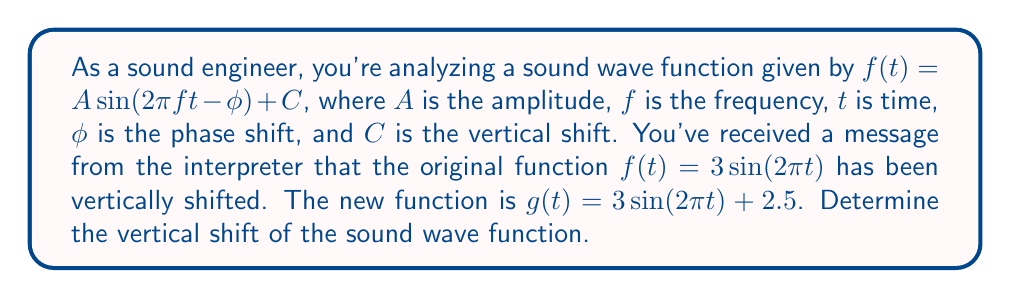Solve this math problem. To determine the vertical shift of a function, we need to compare the original function with the transformed function. Let's analyze this step-by-step:

1) The original function is:
   $f(t) = 3 \sin(2\pi t)$

2) The new function is:
   $g(t) = 3 \sin(2\pi t) + 2.5$

3) The general form of a vertically shifted sine function is:
   $y = A \sin(B(x - C)) + D$
   where $D$ represents the vertical shift.

4) Comparing our original and new functions to this general form:
   $f(t) = 3 \sin(2\pi t) + 0$
   $g(t) = 3 \sin(2\pi t) + 2.5$

5) We can see that the only difference between these functions is the constant term added at the end. This constant term represents the vertical shift.

6) The vertical shift is the difference between the constant terms:
   Vertical shift = $2.5 - 0 = 2.5$

Therefore, the sound wave function has been shifted 2.5 units upward.
Answer: The vertical shift of the sound wave function is 2.5 units upward. 